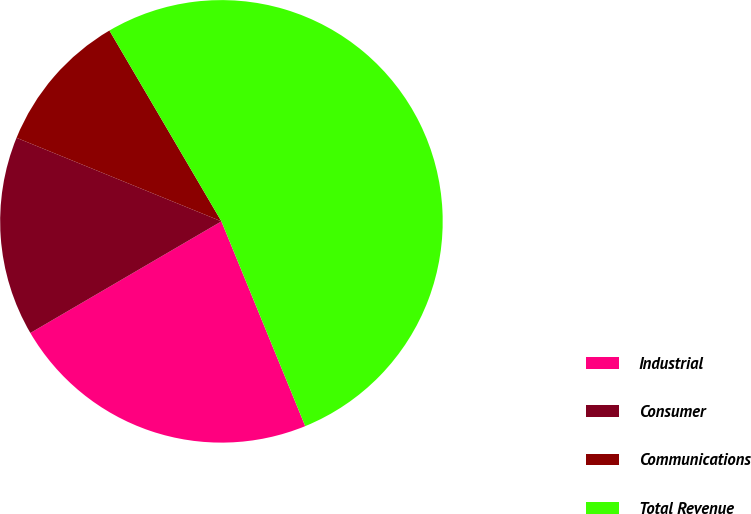Convert chart. <chart><loc_0><loc_0><loc_500><loc_500><pie_chart><fcel>Industrial<fcel>Consumer<fcel>Communications<fcel>Total Revenue<nl><fcel>22.77%<fcel>14.58%<fcel>10.39%<fcel>52.27%<nl></chart> 